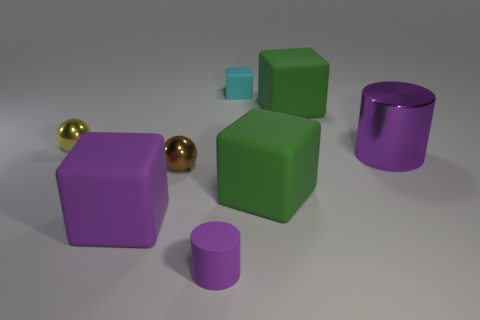There is a tiny cylinder that is made of the same material as the cyan block; what color is it?
Give a very brief answer. Purple. There is a metallic cylinder in front of the small yellow object; is it the same color as the matte cylinder?
Your answer should be very brief. Yes. What is the big purple thing on the left side of the large metallic object made of?
Offer a very short reply. Rubber. Are there the same number of small yellow balls that are behind the yellow metal sphere and big cyan matte cubes?
Your answer should be very brief. Yes. What number of other small matte cubes have the same color as the tiny block?
Offer a very short reply. 0. There is another small metal thing that is the same shape as the yellow metallic thing; what color is it?
Offer a very short reply. Brown. Do the brown shiny sphere and the purple rubber block have the same size?
Provide a succinct answer. No. Is the number of big shiny objects that are in front of the large cylinder the same as the number of small brown metal spheres right of the brown thing?
Provide a succinct answer. Yes. Are there any large red rubber cubes?
Your response must be concise. No. What is the size of the brown object that is the same shape as the yellow metal thing?
Your response must be concise. Small. 